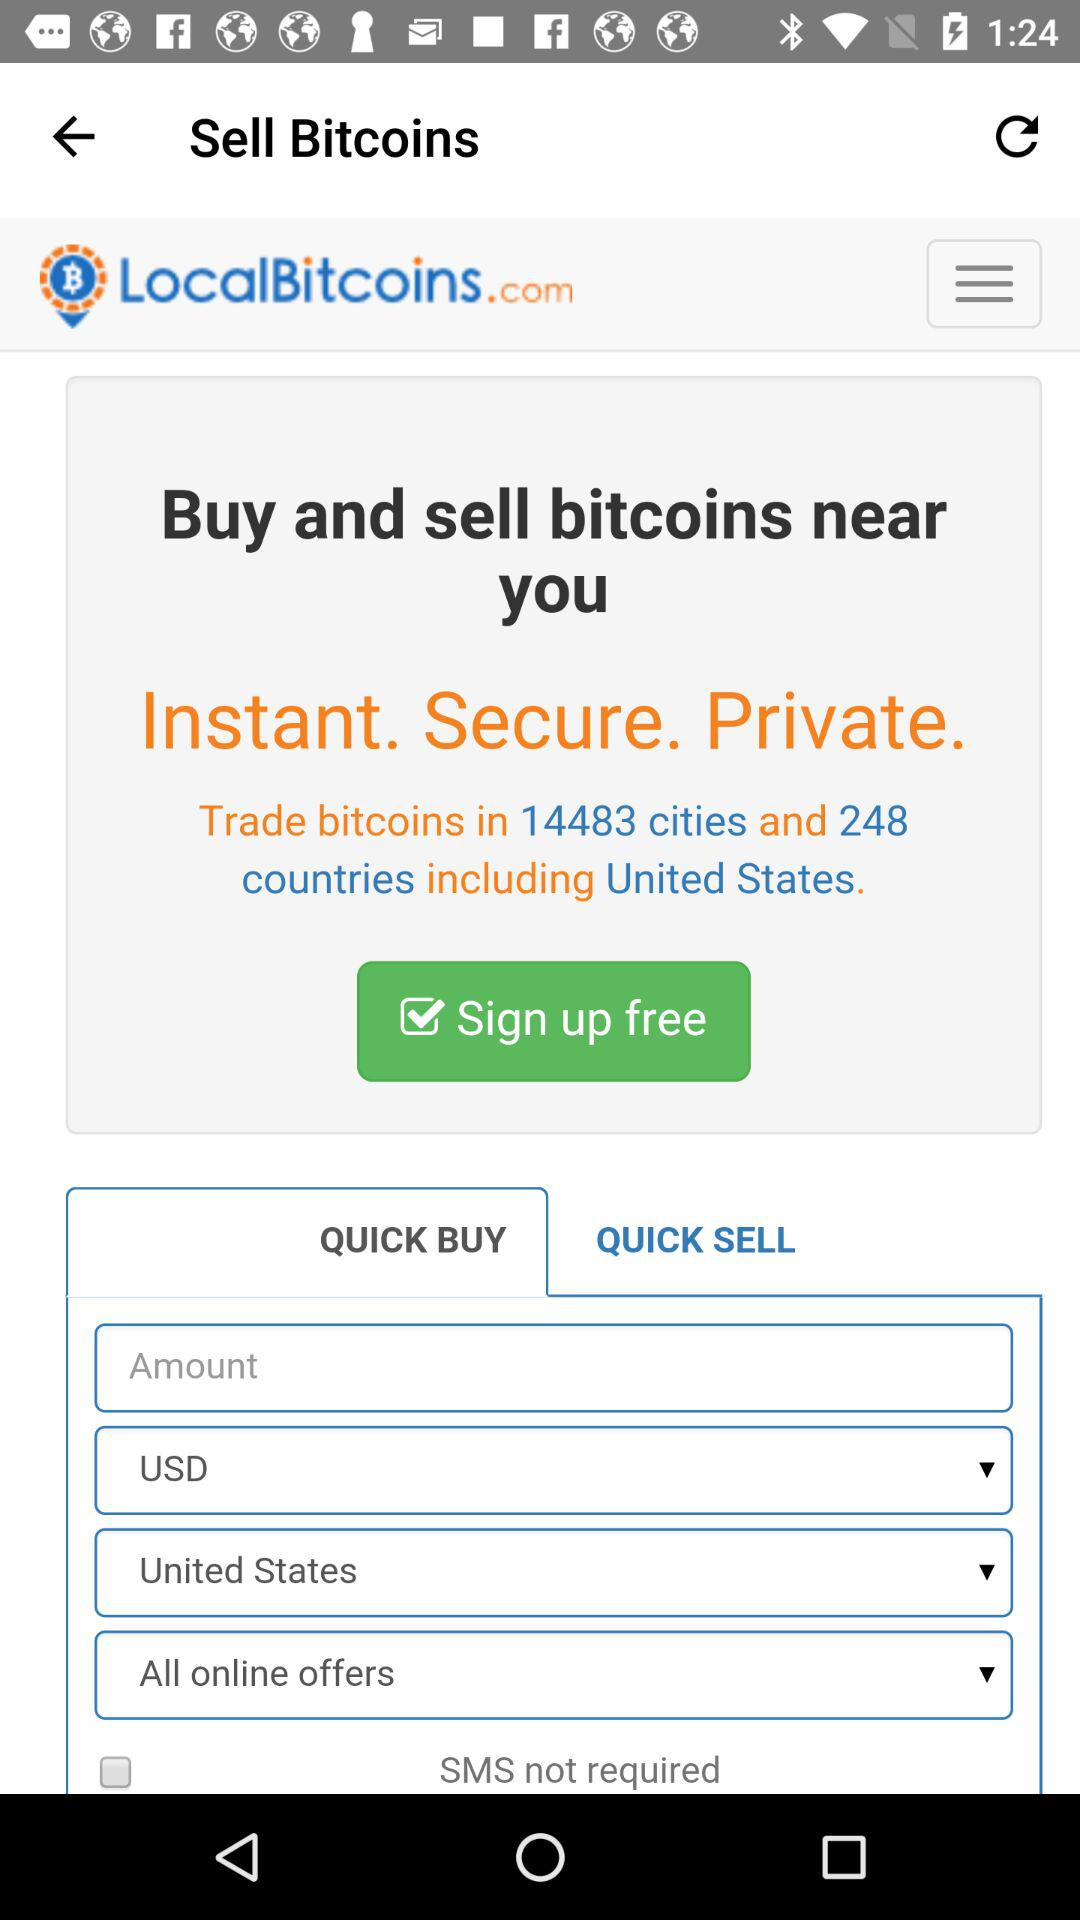What website is used for trading bitcoins?
Answer the question using a single word or phrase. It is LocalBitcoins.com. 